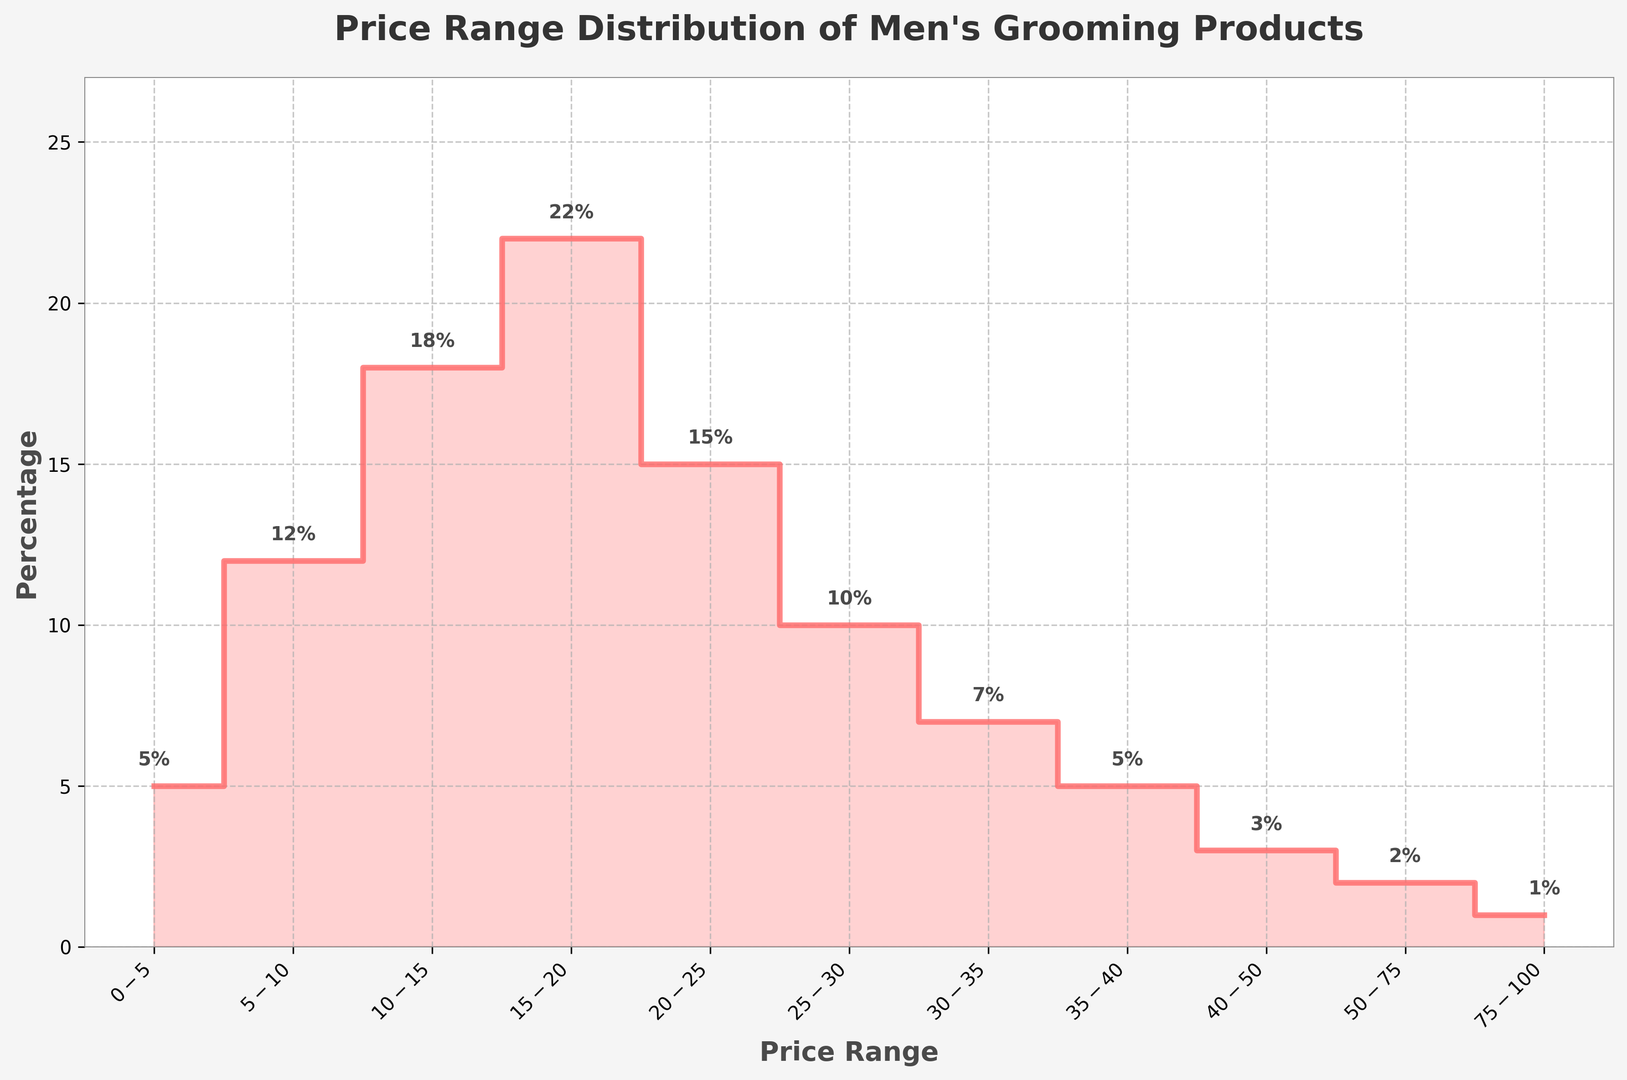What is the most common price range for men's grooming products based on the figure? The price range with the highest percentage on the vertical axis is $15-$20, which is indicated by the tallest step.
Answer: $15-$20 Which price range has a higher percentage of products, $10-$15 or $20-$25? The two price ranges $10-$15 and $20-$25 have percentages of 18% and 15% respectively. By comparing these values, $10-$15 has a higher percentage.
Answer: $10-$15 What is the total percentage of products priced between $0-$10? The total percentage is the sum of the percentages for $0-$5 (5%) and $5-$10 (12%). Adding these gives 5% + 12% = 17%.
Answer: 17% How does the percentage of products within the $25-$35 range compare to those between $50-$100? The $25-$35 range has 10% ($25-$30) + 7% ($30-$35) = 17%, while $50-$75 and $75-$100 have 2% and 1% respectively. So, 17% is significantly higher than 3%.
Answer: $25-$35 range is higher What is the visual indication that the $15-$20 range has the largest percentage? The $15-$20 range is visually indicated with the highest step in the stairs plot, meaning it reaches the greatest height on the y-axis.
Answer: Highest step Which price ranges have the smallest percentage of products? The smallest percentages are found in the $50-$75 (2%) and $75-$100 (1%) ranges, indicated by the shortest steps in the plot.
Answer: $50-$75, $75-$100 What trends can be observed about the distribution of prices? There is an increasing trend from $0-$5 to $15-$20 and a decreasing trend from $15-$20 onwards, indicating more products are priced between $10-$25.
Answer: Increasing then decreasing trend If you combine the percentages for products priced above $25, what is the total percentage? The total percentage for products above $25 is the sum of percentages for $25-$30 (10%), $30-$35 (7%), $35-$40 (5%), $40-$50 (3%), $50-$75 (2%), and $75-$100 (1%). Adding these gives 10% + 7% + 5% + 3% + 2% + 1% = 28%.
Answer: 28% Is there a noticeable drop in percentage after a certain price range? Yes, there is a noticeable drop after the $15-$20 range, as the percentages for higher price ranges gradually decrease.
Answer: After $15-$20 What percentage of products fall within the most common price range and the immediately less common price range combined? The most common price range is $15-$20 (22%) and the next most common is $10-$15 (18%). Combining these gives 22% + 18% = 40%.
Answer: 40% 